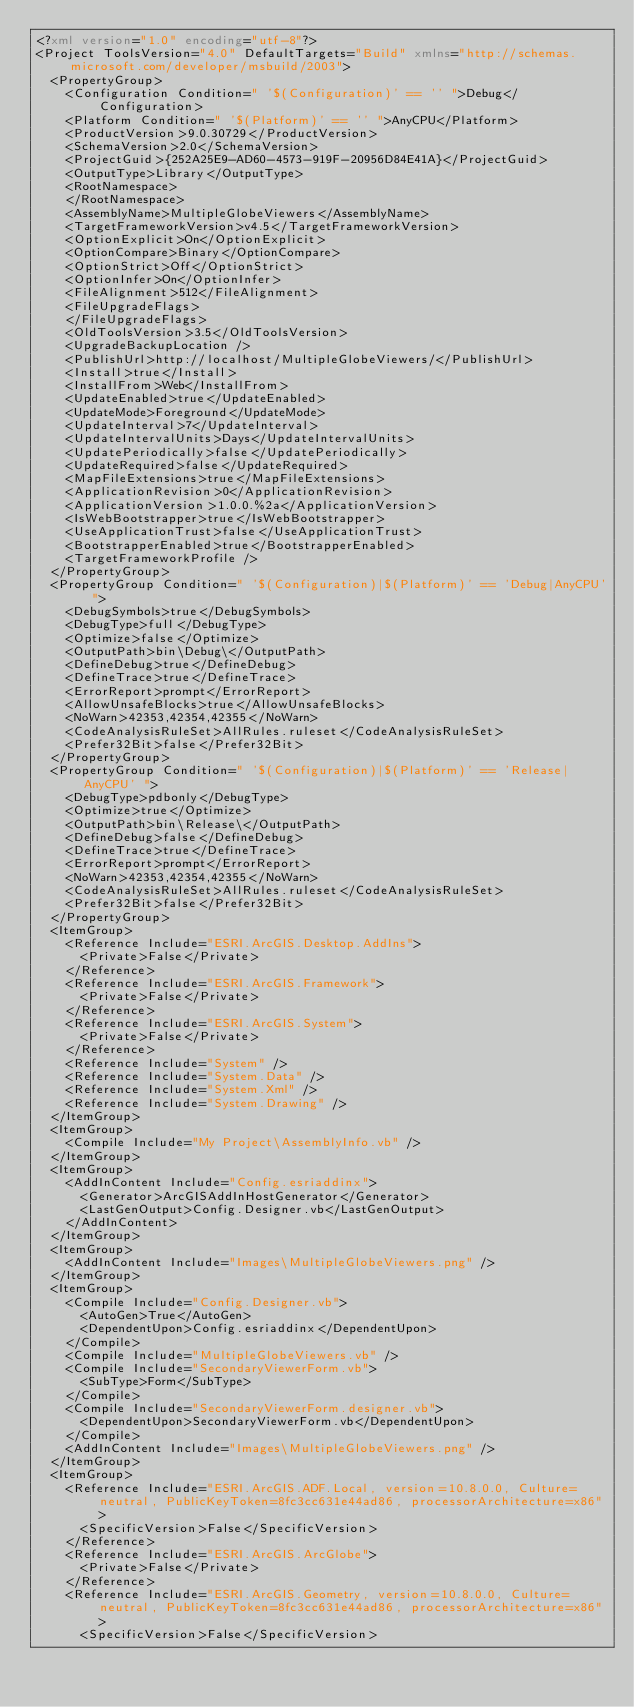<code> <loc_0><loc_0><loc_500><loc_500><_XML_><?xml version="1.0" encoding="utf-8"?>
<Project ToolsVersion="4.0" DefaultTargets="Build" xmlns="http://schemas.microsoft.com/developer/msbuild/2003">
  <PropertyGroup>
    <Configuration Condition=" '$(Configuration)' == '' ">Debug</Configuration>
    <Platform Condition=" '$(Platform)' == '' ">AnyCPU</Platform>
    <ProductVersion>9.0.30729</ProductVersion>
    <SchemaVersion>2.0</SchemaVersion>
    <ProjectGuid>{252A25E9-AD60-4573-919F-20956D84E41A}</ProjectGuid>
    <OutputType>Library</OutputType>
    <RootNamespace>
    </RootNamespace>
    <AssemblyName>MultipleGlobeViewers</AssemblyName>
    <TargetFrameworkVersion>v4.5</TargetFrameworkVersion>
    <OptionExplicit>On</OptionExplicit>
    <OptionCompare>Binary</OptionCompare>
    <OptionStrict>Off</OptionStrict>
    <OptionInfer>On</OptionInfer>
    <FileAlignment>512</FileAlignment>
    <FileUpgradeFlags>
    </FileUpgradeFlags>
    <OldToolsVersion>3.5</OldToolsVersion>
    <UpgradeBackupLocation />
    <PublishUrl>http://localhost/MultipleGlobeViewers/</PublishUrl>
    <Install>true</Install>
    <InstallFrom>Web</InstallFrom>
    <UpdateEnabled>true</UpdateEnabled>
    <UpdateMode>Foreground</UpdateMode>
    <UpdateInterval>7</UpdateInterval>
    <UpdateIntervalUnits>Days</UpdateIntervalUnits>
    <UpdatePeriodically>false</UpdatePeriodically>
    <UpdateRequired>false</UpdateRequired>
    <MapFileExtensions>true</MapFileExtensions>
    <ApplicationRevision>0</ApplicationRevision>
    <ApplicationVersion>1.0.0.%2a</ApplicationVersion>
    <IsWebBootstrapper>true</IsWebBootstrapper>
    <UseApplicationTrust>false</UseApplicationTrust>
    <BootstrapperEnabled>true</BootstrapperEnabled>
    <TargetFrameworkProfile />
  </PropertyGroup>
  <PropertyGroup Condition=" '$(Configuration)|$(Platform)' == 'Debug|AnyCPU' ">
    <DebugSymbols>true</DebugSymbols>
    <DebugType>full</DebugType>
    <Optimize>false</Optimize>
    <OutputPath>bin\Debug\</OutputPath>
    <DefineDebug>true</DefineDebug>
    <DefineTrace>true</DefineTrace>
    <ErrorReport>prompt</ErrorReport>
    <AllowUnsafeBlocks>true</AllowUnsafeBlocks>
    <NoWarn>42353,42354,42355</NoWarn>
    <CodeAnalysisRuleSet>AllRules.ruleset</CodeAnalysisRuleSet>
    <Prefer32Bit>false</Prefer32Bit>
  </PropertyGroup>
  <PropertyGroup Condition=" '$(Configuration)|$(Platform)' == 'Release|AnyCPU' ">
    <DebugType>pdbonly</DebugType>
    <Optimize>true</Optimize>
    <OutputPath>bin\Release\</OutputPath>
    <DefineDebug>false</DefineDebug>
    <DefineTrace>true</DefineTrace>
    <ErrorReport>prompt</ErrorReport>
    <NoWarn>42353,42354,42355</NoWarn>
    <CodeAnalysisRuleSet>AllRules.ruleset</CodeAnalysisRuleSet>
    <Prefer32Bit>false</Prefer32Bit>
  </PropertyGroup>
  <ItemGroup>
    <Reference Include="ESRI.ArcGIS.Desktop.AddIns">
      <Private>False</Private>
    </Reference>
    <Reference Include="ESRI.ArcGIS.Framework">
      <Private>False</Private>
    </Reference>
    <Reference Include="ESRI.ArcGIS.System">
      <Private>False</Private>
    </Reference>
    <Reference Include="System" />
    <Reference Include="System.Data" />
    <Reference Include="System.Xml" />
    <Reference Include="System.Drawing" />
  </ItemGroup>
  <ItemGroup>
    <Compile Include="My Project\AssemblyInfo.vb" />
  </ItemGroup>
  <ItemGroup>
    <AddInContent Include="Config.esriaddinx">
      <Generator>ArcGISAddInHostGenerator</Generator>
      <LastGenOutput>Config.Designer.vb</LastGenOutput>
    </AddInContent>
  </ItemGroup>
  <ItemGroup>
    <AddInContent Include="Images\MultipleGlobeViewers.png" />
  </ItemGroup>
  <ItemGroup>
    <Compile Include="Config.Designer.vb">
      <AutoGen>True</AutoGen>
      <DependentUpon>Config.esriaddinx</DependentUpon>
    </Compile>
    <Compile Include="MultipleGlobeViewers.vb" />
    <Compile Include="SecondaryViewerForm.vb">
      <SubType>Form</SubType>
    </Compile>
    <Compile Include="SecondaryViewerForm.designer.vb">
      <DependentUpon>SecondaryViewerForm.vb</DependentUpon>
    </Compile>
    <AddInContent Include="Images\MultipleGlobeViewers.png" />
  </ItemGroup>
  <ItemGroup>
    <Reference Include="ESRI.ArcGIS.ADF.Local, version=10.8.0.0, Culture=neutral, PublicKeyToken=8fc3cc631e44ad86, processorArchitecture=x86">
      <SpecificVersion>False</SpecificVersion>
    </Reference>
    <Reference Include="ESRI.ArcGIS.ArcGlobe">
      <Private>False</Private>
    </Reference>
    <Reference Include="ESRI.ArcGIS.Geometry, version=10.8.0.0, Culture=neutral, PublicKeyToken=8fc3cc631e44ad86, processorArchitecture=x86">
      <SpecificVersion>False</SpecificVersion></code> 